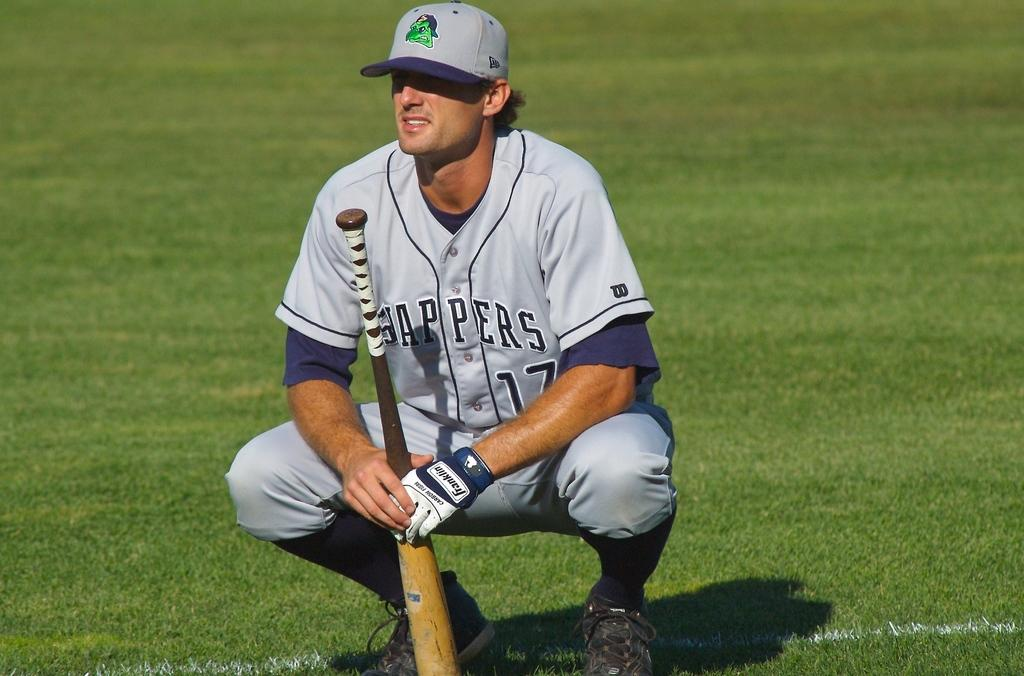<image>
Create a compact narrative representing the image presented. A baseball playyer with the number 17 on his outfit. 